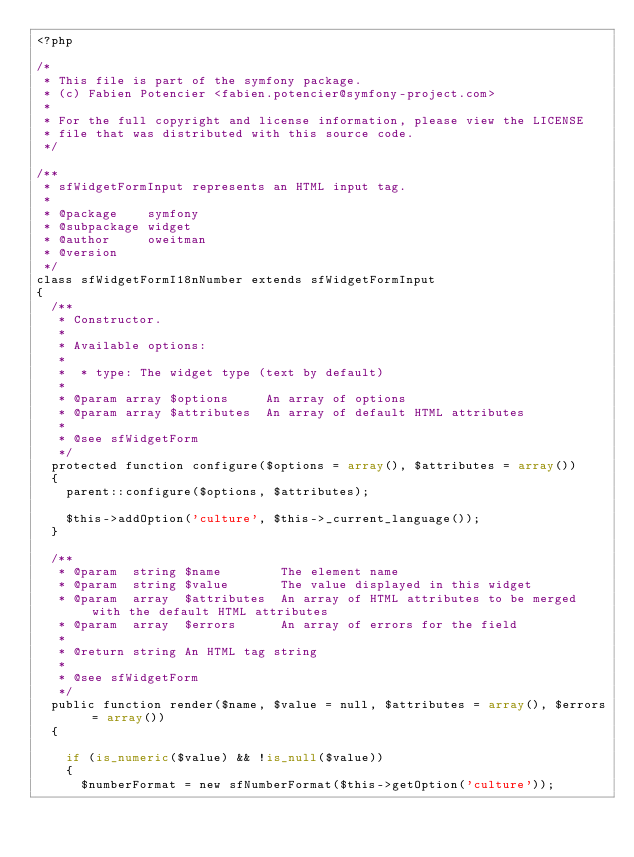<code> <loc_0><loc_0><loc_500><loc_500><_PHP_><?php

/*
 * This file is part of the symfony package.
 * (c) Fabien Potencier <fabien.potencier@symfony-project.com>
 * 
 * For the full copyright and license information, please view the LICENSE
 * file that was distributed with this source code.
 */

/**
 * sfWidgetFormInput represents an HTML input tag.
 *
 * @package    symfony
 * @subpackage widget
 * @author     oweitman
 * @version    
 */
class sfWidgetFormI18nNumber extends sfWidgetFormInput
{
  /**
   * Constructor.
   *
   * Available options:
   *
   *  * type: The widget type (text by default)
   *
   * @param array $options     An array of options
   * @param array $attributes  An array of default HTML attributes
   *
   * @see sfWidgetForm
   */
  protected function configure($options = array(), $attributes = array())
  {
    parent::configure($options, $attributes);

    $this->addOption('culture', $this->_current_language());
  }

  /**
   * @param  string $name        The element name
   * @param  string $value       The value displayed in this widget
   * @param  array  $attributes  An array of HTML attributes to be merged with the default HTML attributes
   * @param  array  $errors      An array of errors for the field
   *
   * @return string An HTML tag string
   *
   * @see sfWidgetForm
   */
  public function render($name, $value = null, $attributes = array(), $errors = array())
  {
    
    if (is_numeric($value) && !is_null($value))
    {
      $numberFormat = new sfNumberFormat($this->getOption('culture'));</code> 